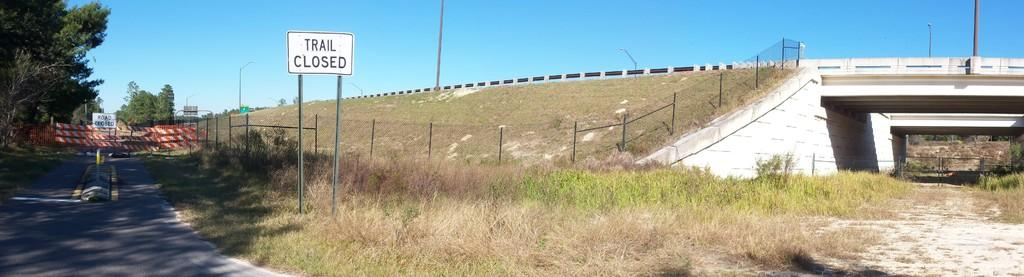What type of vegetation is in the middle of the image? There is grass in the middle of the image. What structure can be seen in the middle of the image? There is a bridge in the middle of the image. What is visible at the top of the image? The sky is visible at the top of the image. What type of vegetation is on the left side of the image? There are trees on the left side of the image. What is the chance of finding a cemetery in the image? There is no mention of a cemetery in the image, so it is impossible to determine the chance of finding one. What thing is being used to cross the grass in the image? The image does not show any object or person crossing the grass, so it is impossible to determine what thing might be used for that purpose. 